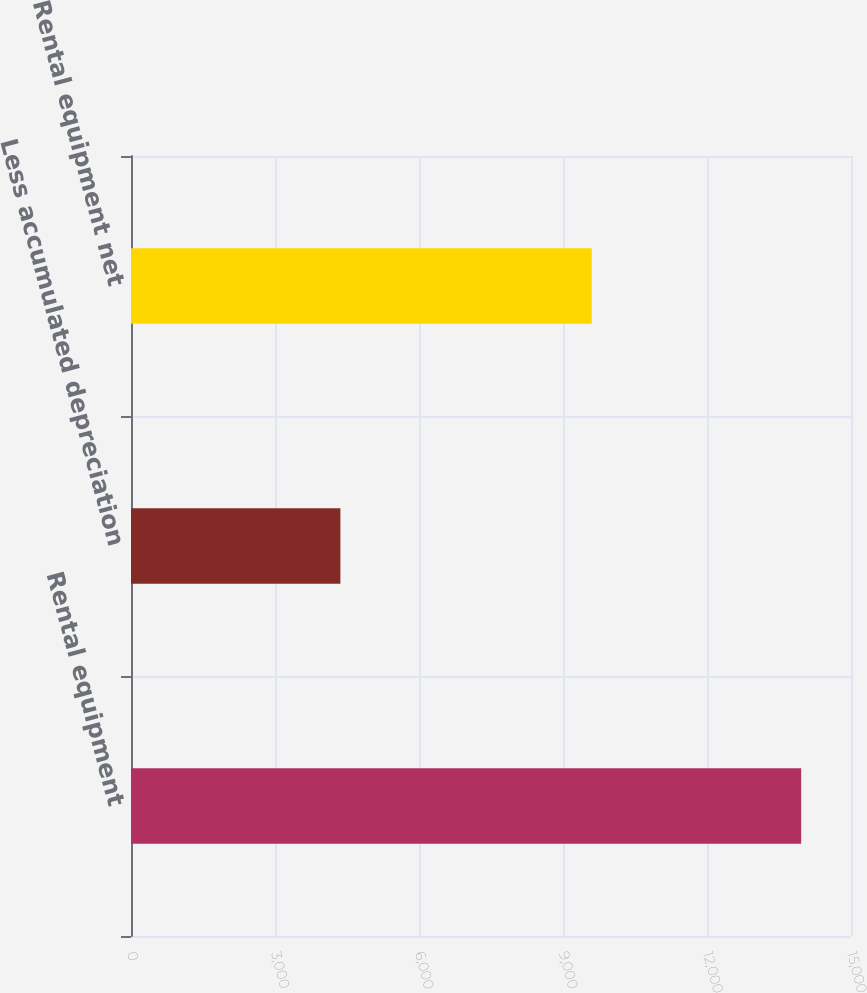Convert chart to OTSL. <chart><loc_0><loc_0><loc_500><loc_500><bar_chart><fcel>Rental equipment<fcel>Less accumulated depreciation<fcel>Rental equipment net<nl><fcel>13962<fcel>4362<fcel>9600<nl></chart> 